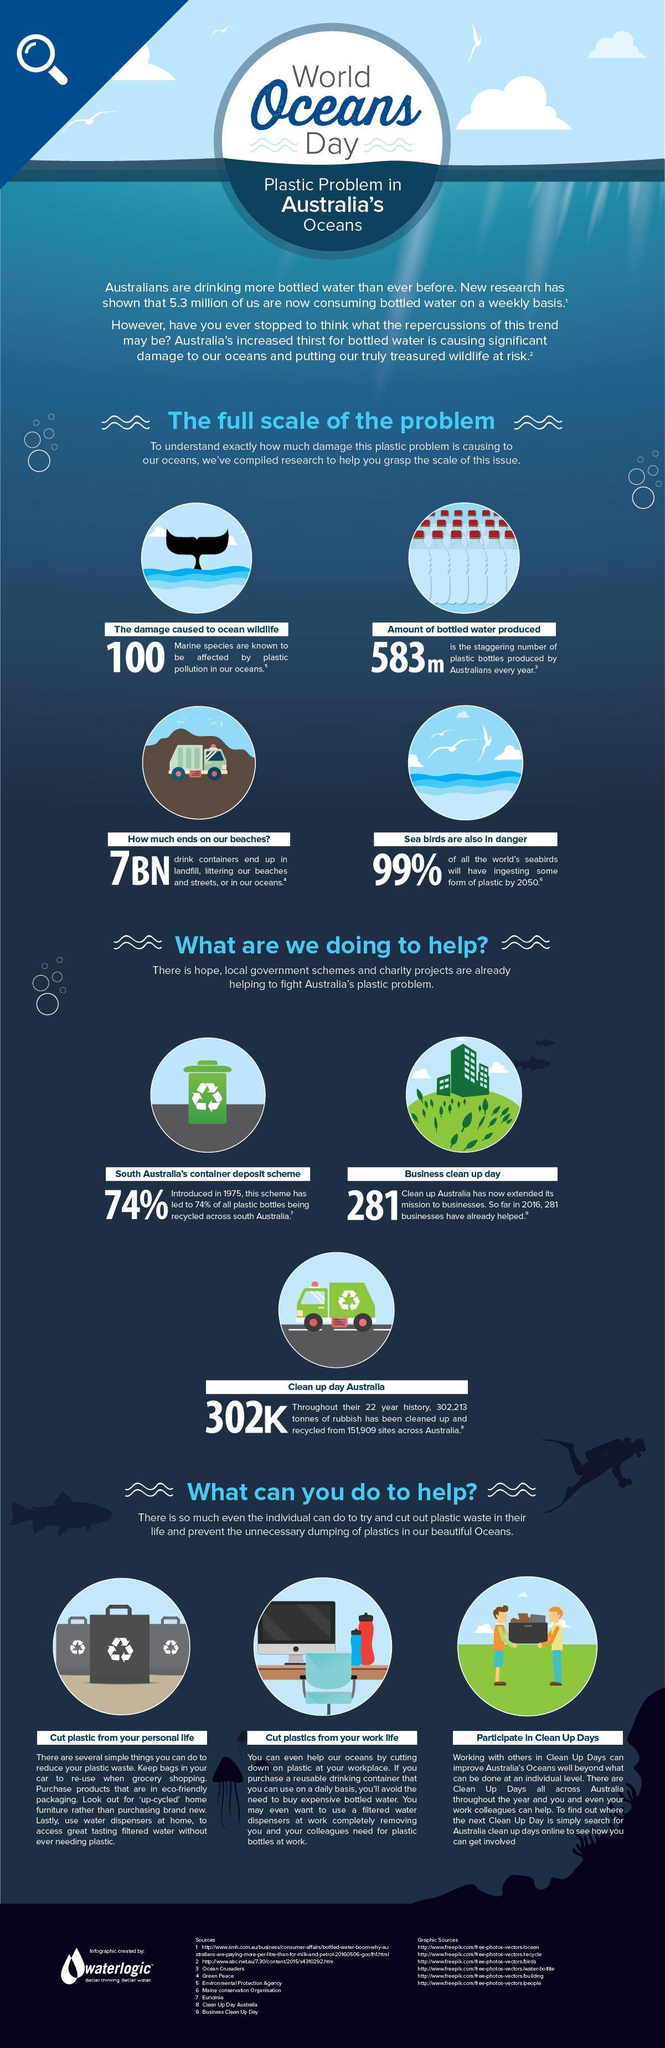What percentage of bottles are being recycled in Australia, 99%, 74%,  or 7% ?
Answer the question with a short phrase. 74% What  is number of oceanic species are affected by plastic pollution,  583, 100, or 7 ? 100 